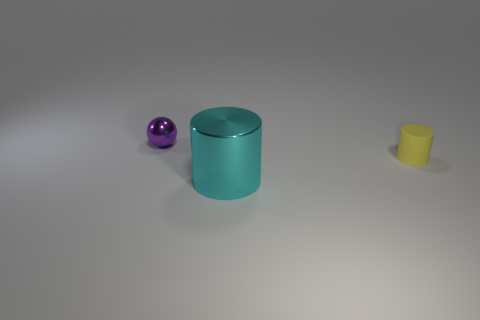Are there any other things that are the same size as the cyan metal cylinder?
Provide a short and direct response. No. What number of small purple objects have the same material as the cyan object?
Make the answer very short. 1. What color is the other thing that is the same material as the purple thing?
Your answer should be very brief. Cyan. The thing that is in front of the thing that is right of the shiny object that is on the right side of the small shiny sphere is made of what material?
Offer a terse response. Metal. There is a object that is right of the cyan metallic cylinder; is its size the same as the small purple metallic thing?
Your answer should be very brief. Yes. What number of large things are either cyan metal cylinders or rubber cylinders?
Ensure brevity in your answer.  1. What shape is the thing that is the same size as the purple shiny sphere?
Ensure brevity in your answer.  Cylinder. How many things are either objects that are on the right side of the purple thing or large brown metallic blocks?
Provide a short and direct response. 2. Are there more small matte objects that are to the right of the cyan shiny thing than tiny yellow things to the right of the tiny rubber thing?
Offer a terse response. Yes. Do the big object and the sphere have the same material?
Your answer should be compact. Yes. 